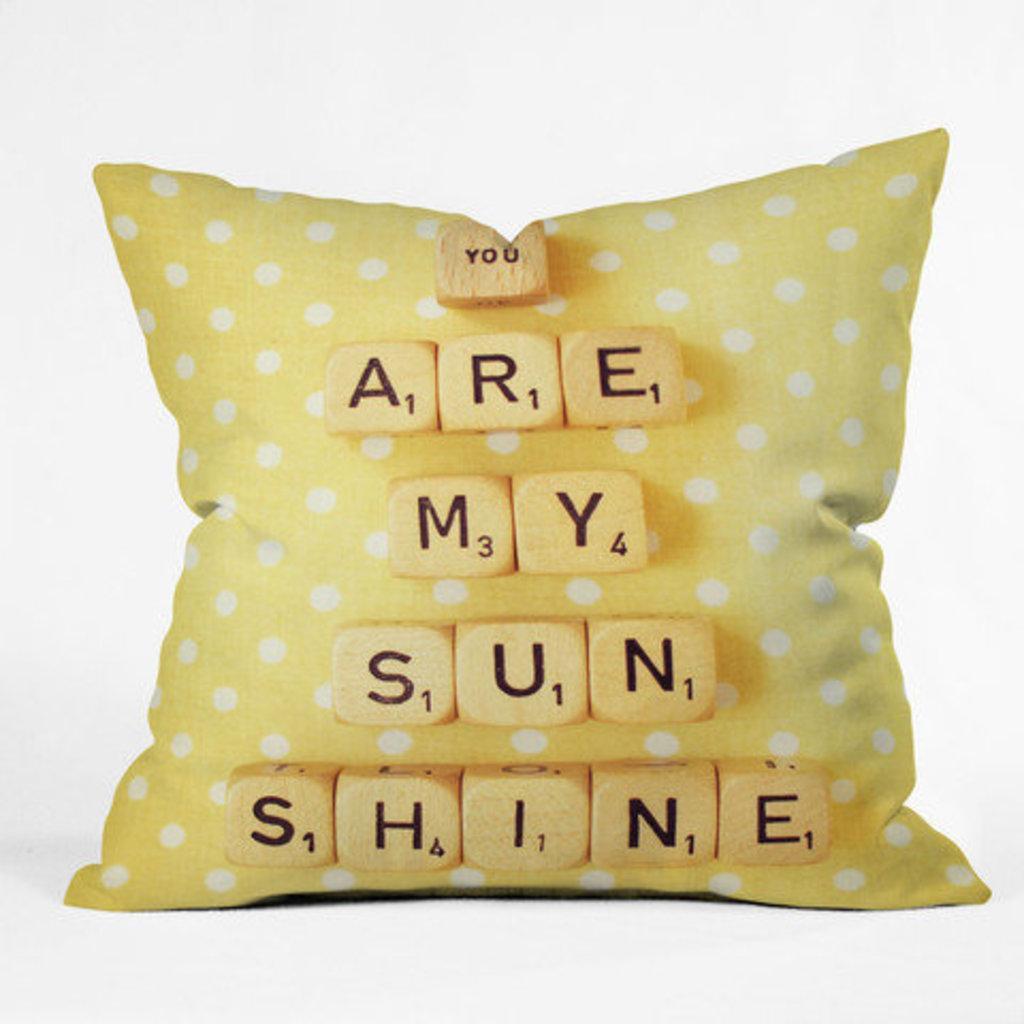Could you give a brief overview of what you see in this image? In this image there is a cushion having some text on it. Background is in white color. 